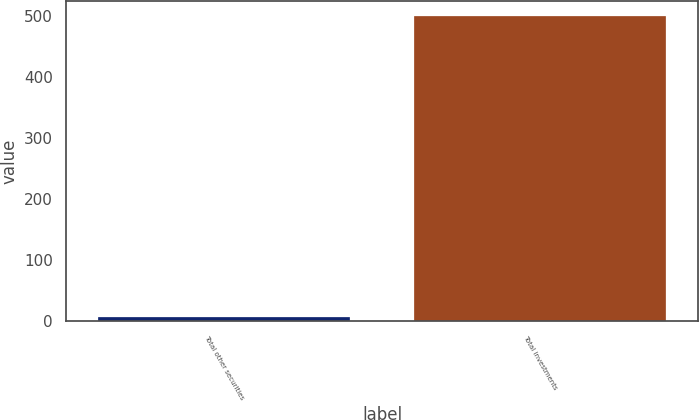Convert chart to OTSL. <chart><loc_0><loc_0><loc_500><loc_500><bar_chart><fcel>Total other securities<fcel>Total investments<nl><fcel>6<fcel>500<nl></chart> 